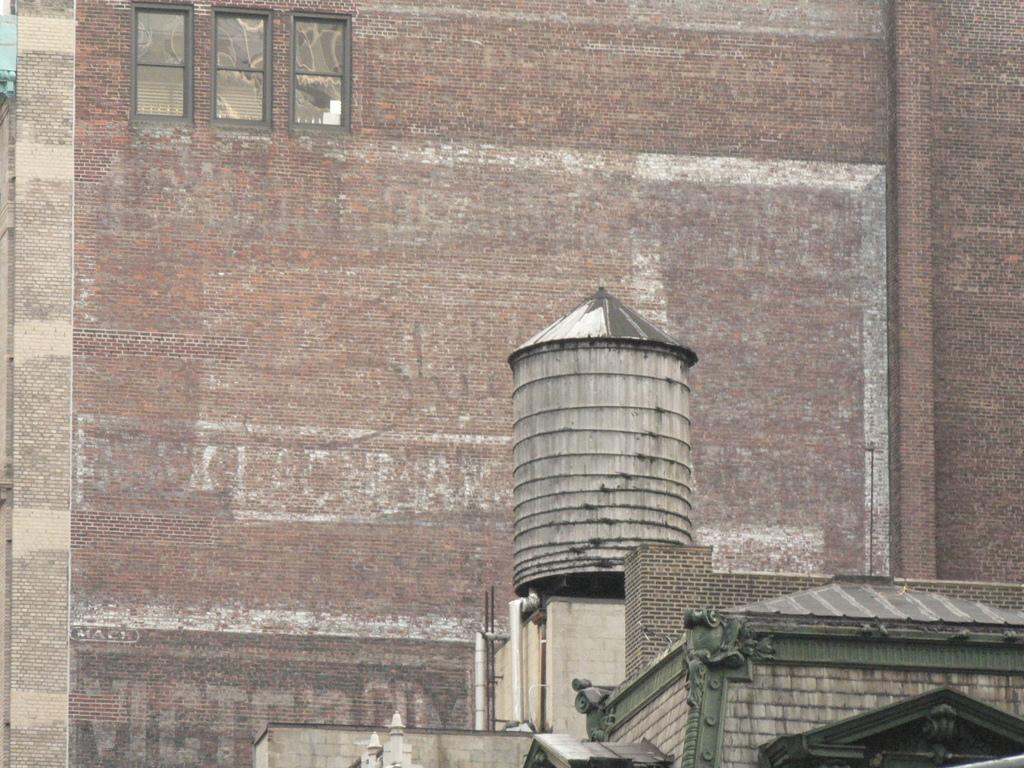What type of structures are present in the image? There are buildings in the image. What feature can be observed on the walls of the buildings? The buildings have windows on their walls. How is the soda distributed among the buildings in the image? There is no soda present in the image, and therefore no distribution can be observed. 